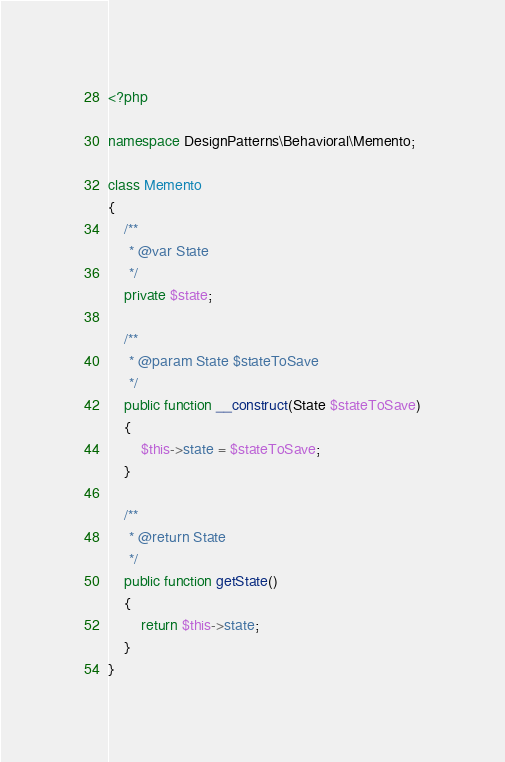Convert code to text. <code><loc_0><loc_0><loc_500><loc_500><_PHP_><?php

namespace DesignPatterns\Behavioral\Memento;

class Memento
{
    /**
     * @var State
     */
    private $state;

    /**
     * @param State $stateToSave
     */
    public function __construct(State $stateToSave)
    {
        $this->state = $stateToSave;
    }

    /**
     * @return State
     */
    public function getState()
    {
        return $this->state;
    }
}
</code> 